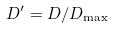Convert formula to latex. <formula><loc_0><loc_0><loc_500><loc_500>D ^ { \prime } = D / D _ { \max }</formula> 